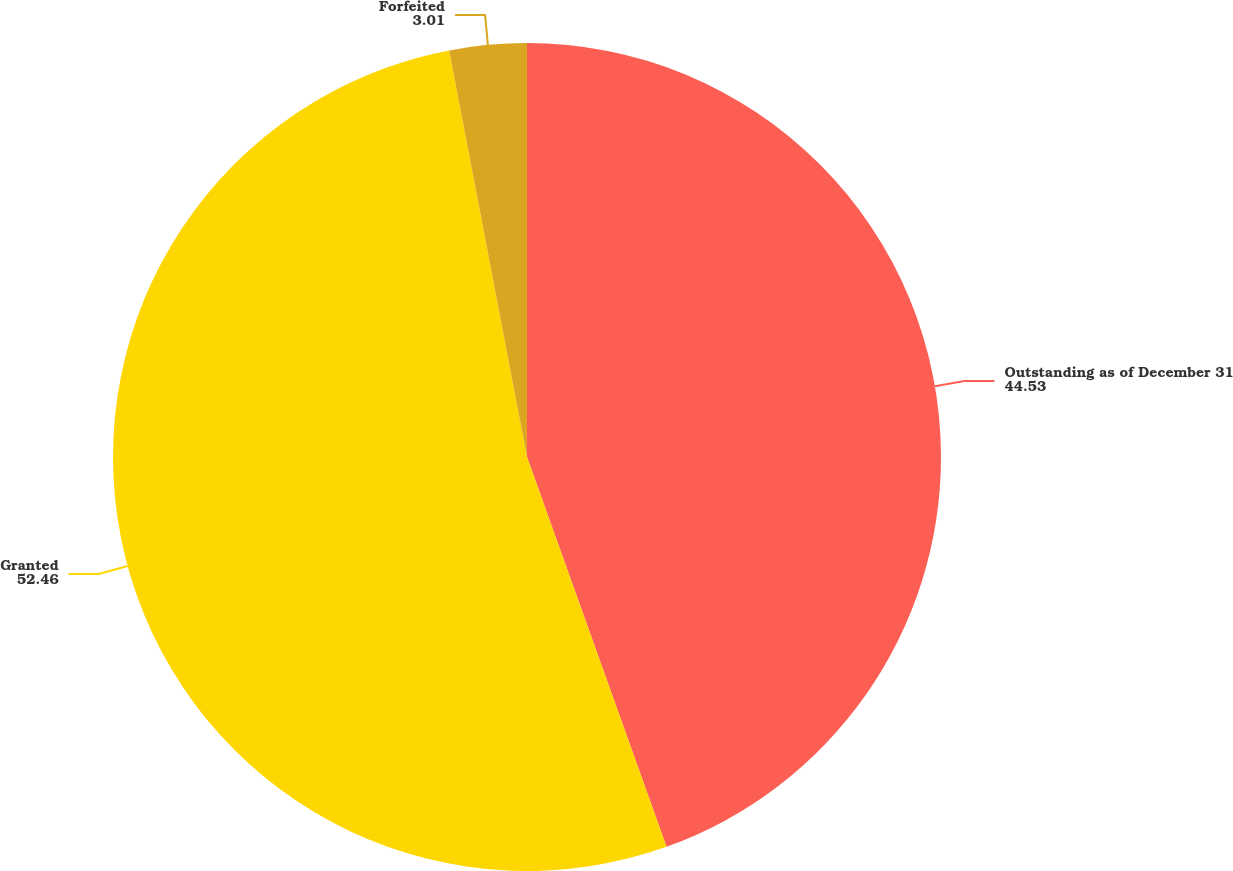Convert chart. <chart><loc_0><loc_0><loc_500><loc_500><pie_chart><fcel>Outstanding as of December 31<fcel>Granted<fcel>Forfeited<nl><fcel>44.53%<fcel>52.46%<fcel>3.01%<nl></chart> 